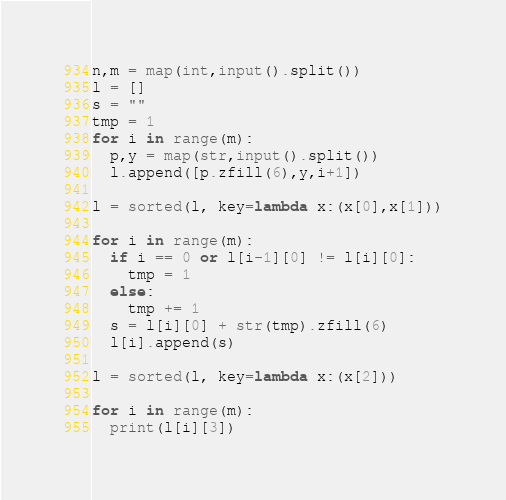Convert code to text. <code><loc_0><loc_0><loc_500><loc_500><_Python_>n,m = map(int,input().split())
l = []
s = ""
tmp = 1
for i in range(m):
  p,y = map(str,input().split())
  l.append([p.zfill(6),y,i+1])
  
l = sorted(l, key=lambda x:(x[0],x[1]))

for i in range(m):
  if i == 0 or l[i-1][0] != l[i][0]:
    tmp = 1
  else:
    tmp += 1
  s = l[i][0] + str(tmp).zfill(6)
  l[i].append(s)
    
l = sorted(l, key=lambda x:(x[2]))

for i in range(m):
  print(l[i][3])</code> 